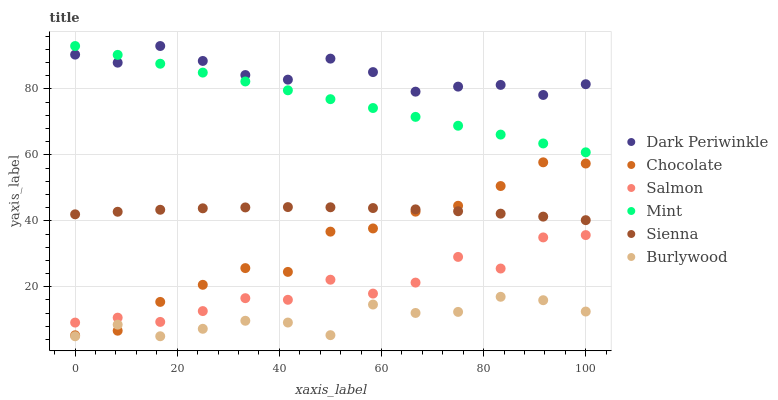Does Burlywood have the minimum area under the curve?
Answer yes or no. Yes. Does Dark Periwinkle have the maximum area under the curve?
Answer yes or no. Yes. Does Salmon have the minimum area under the curve?
Answer yes or no. No. Does Salmon have the maximum area under the curve?
Answer yes or no. No. Is Mint the smoothest?
Answer yes or no. Yes. Is Salmon the roughest?
Answer yes or no. Yes. Is Chocolate the smoothest?
Answer yes or no. No. Is Chocolate the roughest?
Answer yes or no. No. Does Burlywood have the lowest value?
Answer yes or no. Yes. Does Salmon have the lowest value?
Answer yes or no. No. Does Dark Periwinkle have the highest value?
Answer yes or no. Yes. Does Salmon have the highest value?
Answer yes or no. No. Is Sienna less than Mint?
Answer yes or no. Yes. Is Mint greater than Sienna?
Answer yes or no. Yes. Does Chocolate intersect Sienna?
Answer yes or no. Yes. Is Chocolate less than Sienna?
Answer yes or no. No. Is Chocolate greater than Sienna?
Answer yes or no. No. Does Sienna intersect Mint?
Answer yes or no. No. 